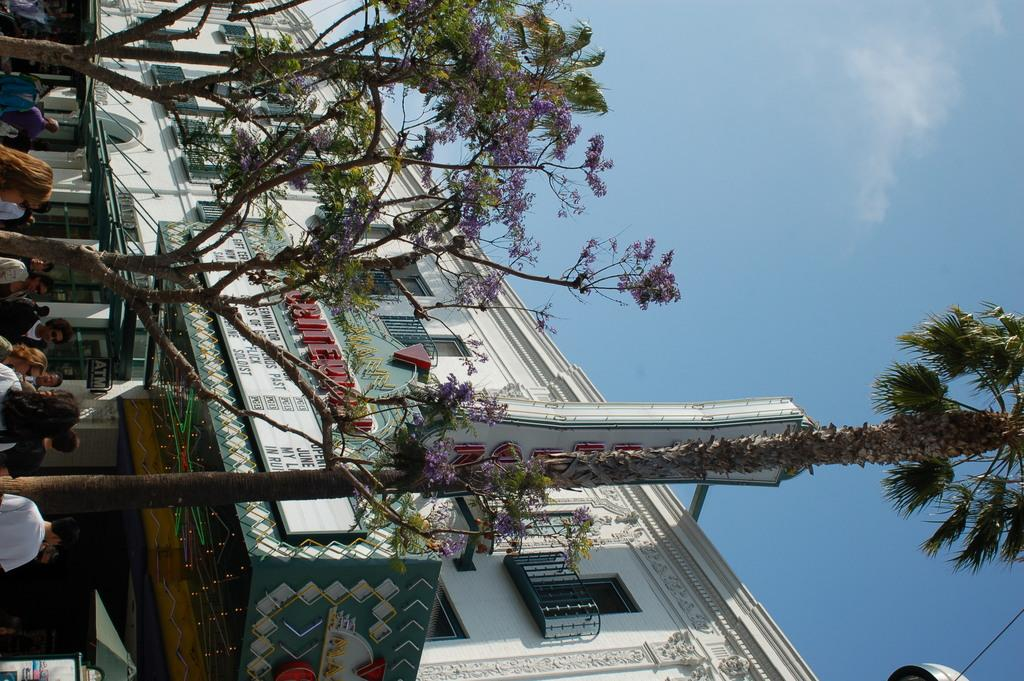What is the main subject in the center of the image? There is a building in the center of the image. What can be seen on the right side of the image? There is a sky visible on the right side of the image. What is present on the left side of the image? There are people on the left side of the image. What type of copper material is used to make the jelly on the left side of the image? There is no jelly or copper material present in the image. How many pieces of pie can be seen on the right side of the image? There is no pie present in the image. 